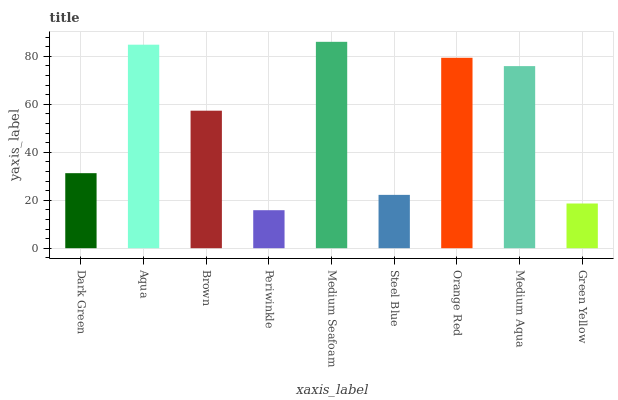Is Periwinkle the minimum?
Answer yes or no. Yes. Is Medium Seafoam the maximum?
Answer yes or no. Yes. Is Aqua the minimum?
Answer yes or no. No. Is Aqua the maximum?
Answer yes or no. No. Is Aqua greater than Dark Green?
Answer yes or no. Yes. Is Dark Green less than Aqua?
Answer yes or no. Yes. Is Dark Green greater than Aqua?
Answer yes or no. No. Is Aqua less than Dark Green?
Answer yes or no. No. Is Brown the high median?
Answer yes or no. Yes. Is Brown the low median?
Answer yes or no. Yes. Is Periwinkle the high median?
Answer yes or no. No. Is Aqua the low median?
Answer yes or no. No. 